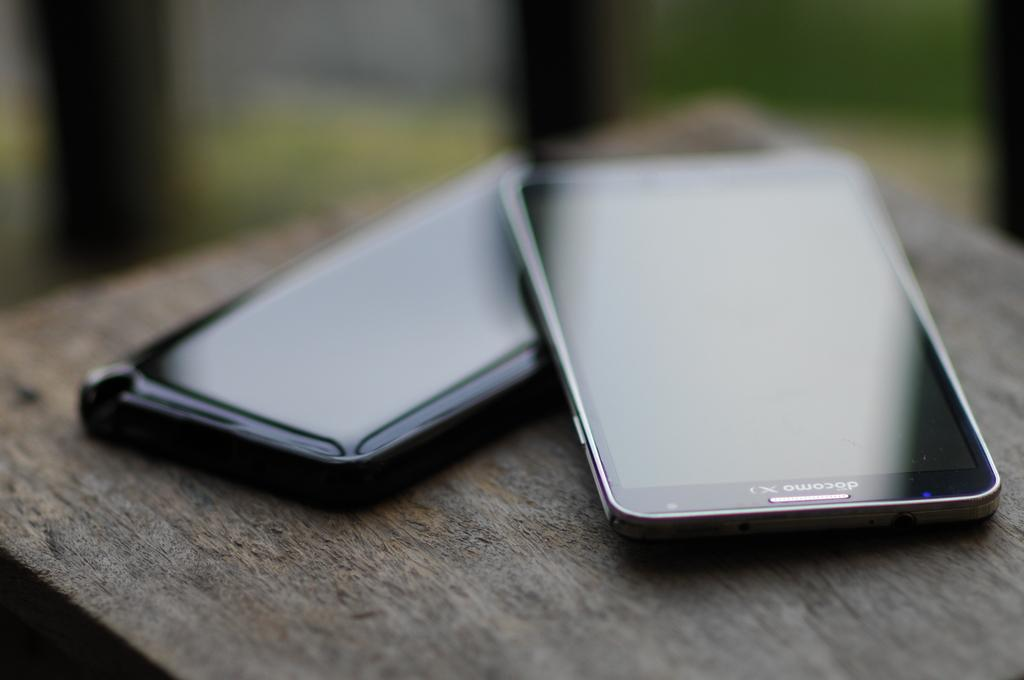<image>
Create a compact narrative representing the image presented. A picture of two Docomo phones being displayed on a table 